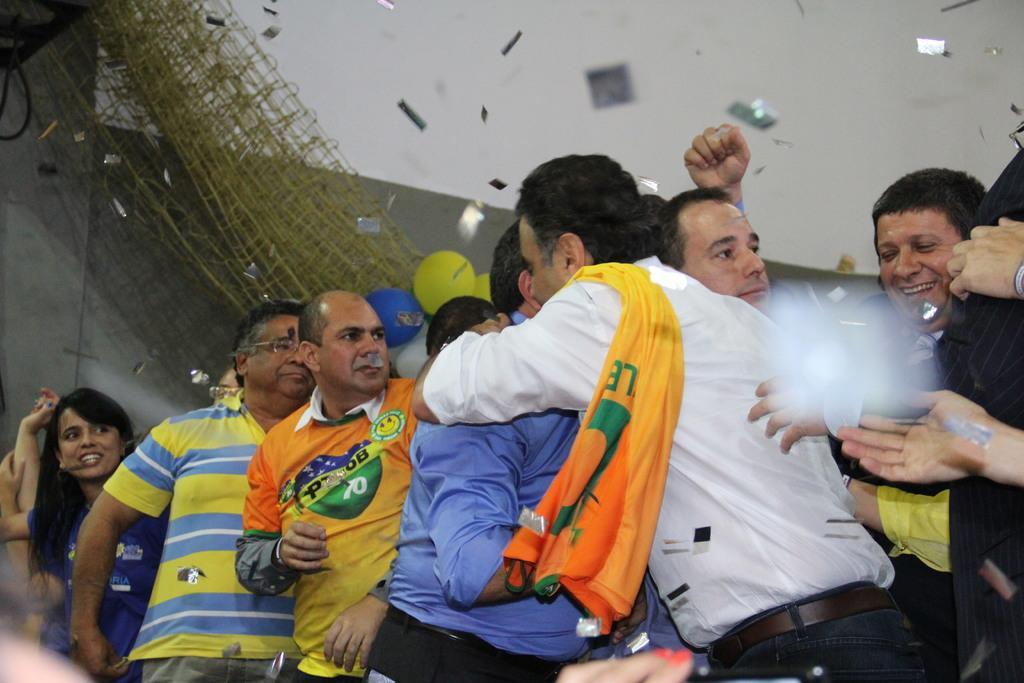How would you summarize this image in a sentence or two? In this image I can see the group of people wearing the different color dresses. In the back I can see colorful balloons, net and the wall. 